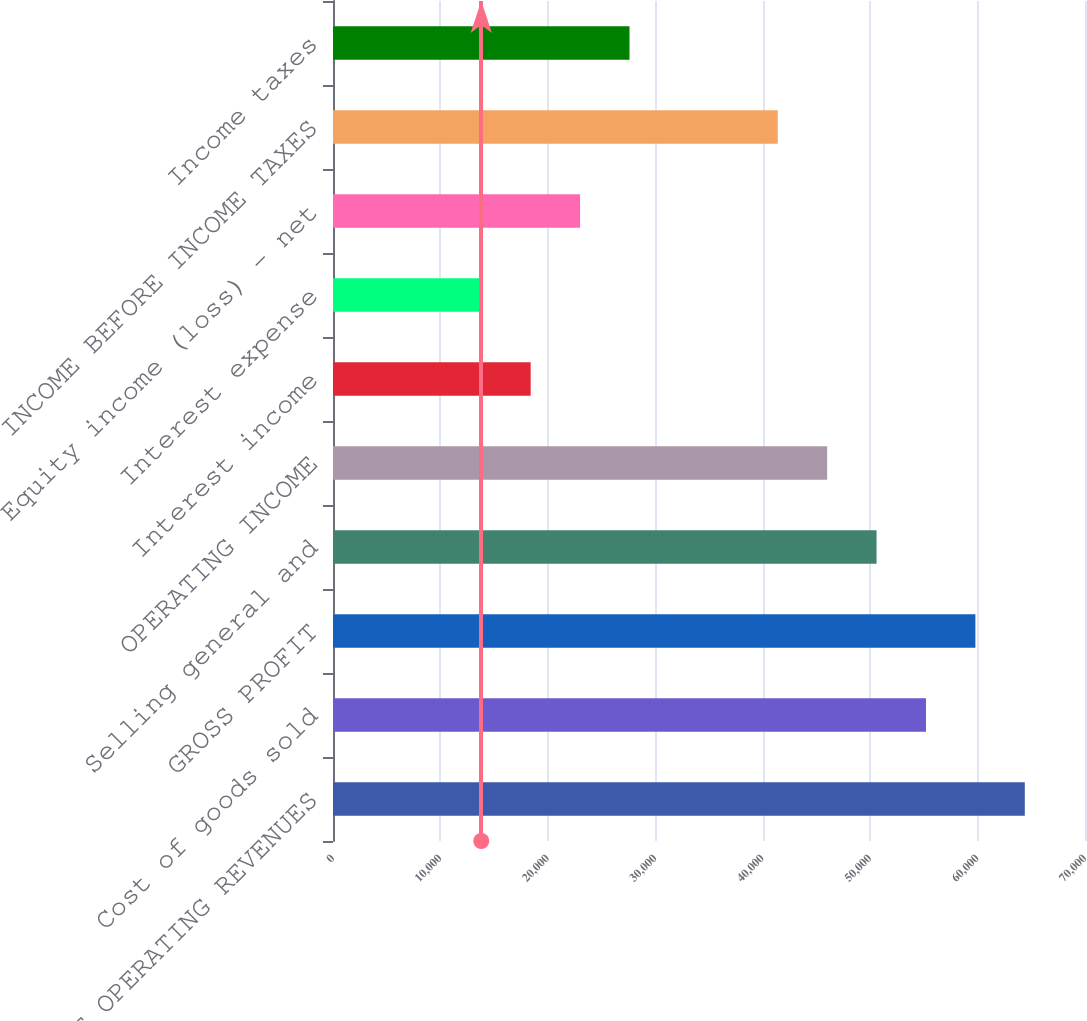Convert chart to OTSL. <chart><loc_0><loc_0><loc_500><loc_500><bar_chart><fcel>NET OPERATING REVENUES<fcel>Cost of goods sold<fcel>GROSS PROFIT<fcel>Selling general and<fcel>OPERATING INCOME<fcel>Interest income<fcel>Interest expense<fcel>Equity income (loss) - net<fcel>INCOME BEFORE INCOME TAXES<fcel>Income taxes<nl><fcel>64396.6<fcel>55197.3<fcel>59796.9<fcel>50597.6<fcel>45998<fcel>18400.2<fcel>13800.5<fcel>22999.8<fcel>41398.4<fcel>27599.4<nl></chart> 